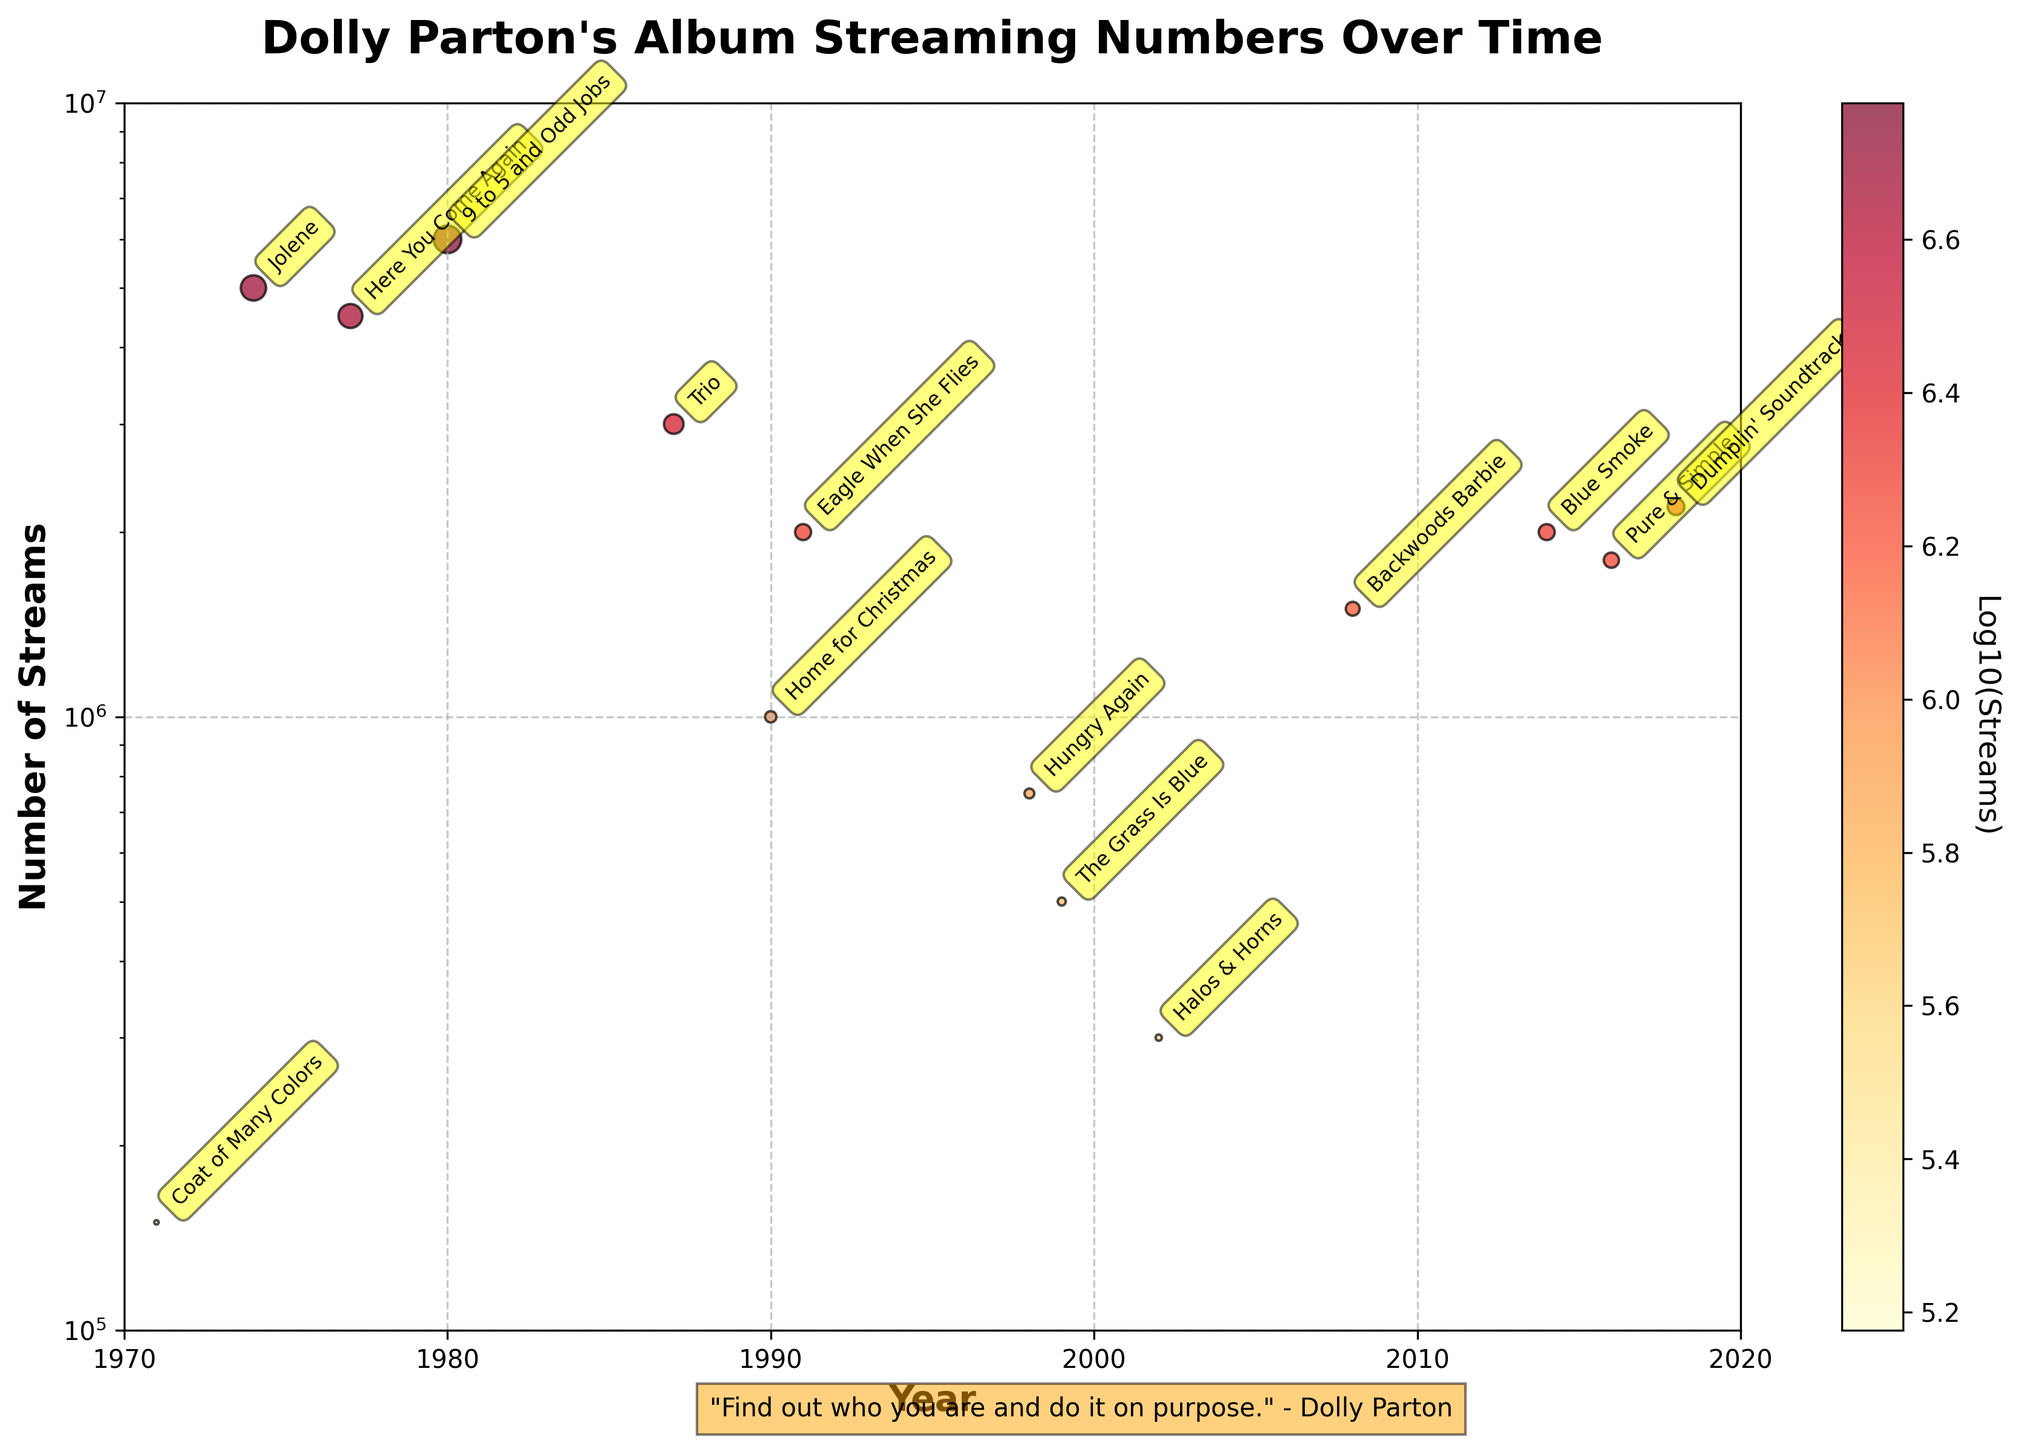Which album has the highest number of streams? The album with the highest number of streams is represented by the data point that is the highest on the y-axis. By looking at the plot, the point at the top corresponds to the album "9 to 5 and Odd Jobs".
Answer: 9 to 5 and Odd Jobs What is the y-axis scale used in the plot? The y-axis scale is a log scale, which is visible because the axis is labeled with powers of 10 (e.g., 1e5 to 1e7). This helps in visualizing data spanning a wide range.
Answer: Logarithmic How many albums have streams greater than 1 million? Count the number of data points above the y-axis value of 1 million. By looking at the plot, there are 10 points that meet this criterion.
Answer: 10 What years are displayed on the x-axis? The x-axis represents years from 1970 to 2020. This is evident from the axis labels at the bottom of the plot.
Answer: 1970 to 2020 Which album from the 1990s has the lowest number of streams? Identify the albums from the 1990s and compare their y-axis positions. "Home for Christmas" from 1990 appears lower on the plot than "Eagle When She Flies" from 1991, indicating fewer streams.
Answer: Home for Christmas How do the streaming numbers for "Jolene" and "Here You Come Again" compare? By comparing their positions on the y-axis, "Jolene" streams are slightly higher than "Here You Come Again". Both are marked in the plot, making it clear that "Jolene" is slightly above "Here You Come Again".
Answer: Jolene is higher What is the trend in streaming numbers over the years? Observing the data points from left to right (1971 to 2018), there's a noticeable variation in heights, suggesting no consistent upward or downward trend, but rather fluctuations over the decades.
Answer: Fluctuating Which decade had albums with the least streams on average? Average the y-axis positions of the albums for each decade. The 2000s had two albums ("Halos & Horns" and "Backwoods Barbie") with relatively lower average streams compared to the other decades.
Answer: 2000s 